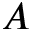<formula> <loc_0><loc_0><loc_500><loc_500>A</formula> 